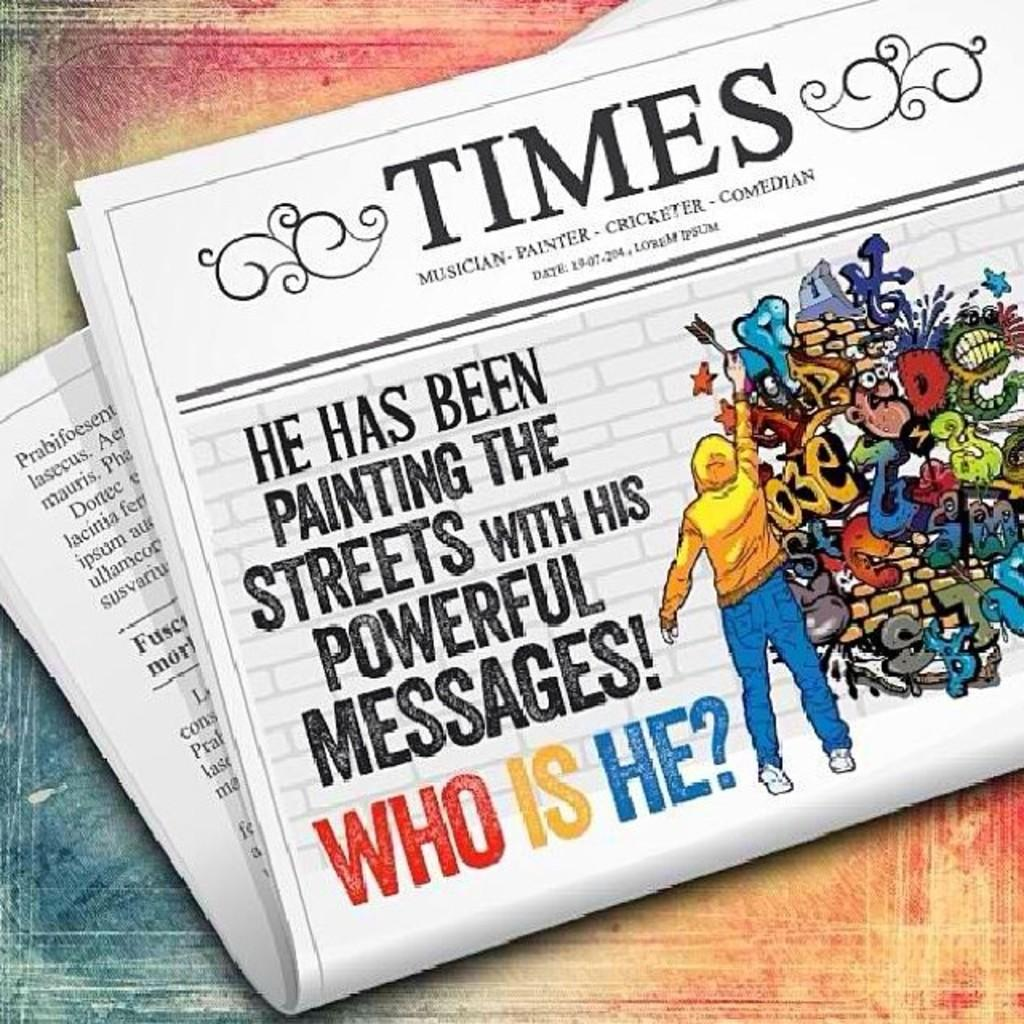<image>
Write a terse but informative summary of the picture. The cover story of the Times is asking about who the person painting powerful messages is. 